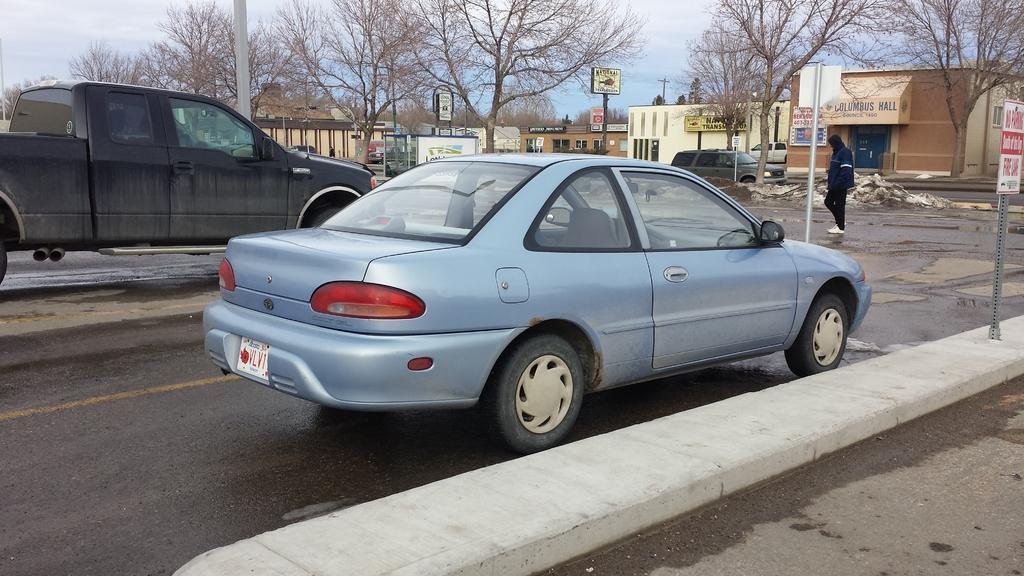How would you summarize this image in a sentence or two? This image consists of cars on the road. In the front, the car is in blue color. It is moving on the road. On the right, there is a man walking. In the background, there are trees and small houses. 